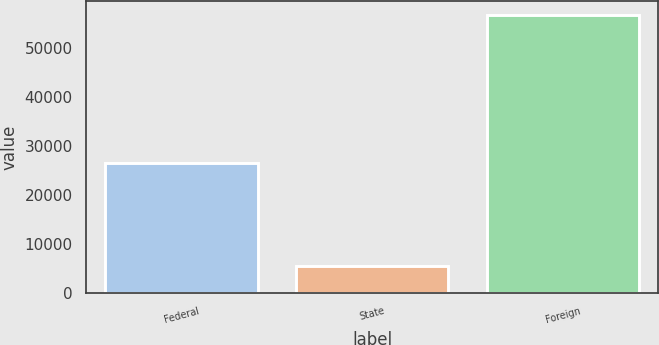Convert chart. <chart><loc_0><loc_0><loc_500><loc_500><bar_chart><fcel>Federal<fcel>State<fcel>Foreign<nl><fcel>26493<fcel>5454<fcel>56689<nl></chart> 